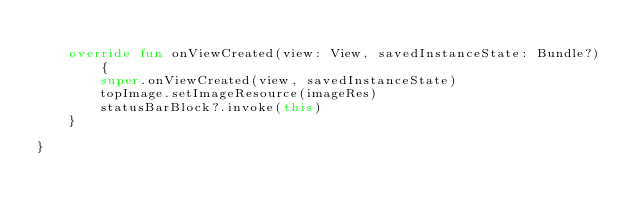<code> <loc_0><loc_0><loc_500><loc_500><_Kotlin_>
    override fun onViewCreated(view: View, savedInstanceState: Bundle?) {
        super.onViewCreated(view, savedInstanceState)
        topImage.setImageResource(imageRes)
        statusBarBlock?.invoke(this)
    }

}</code> 